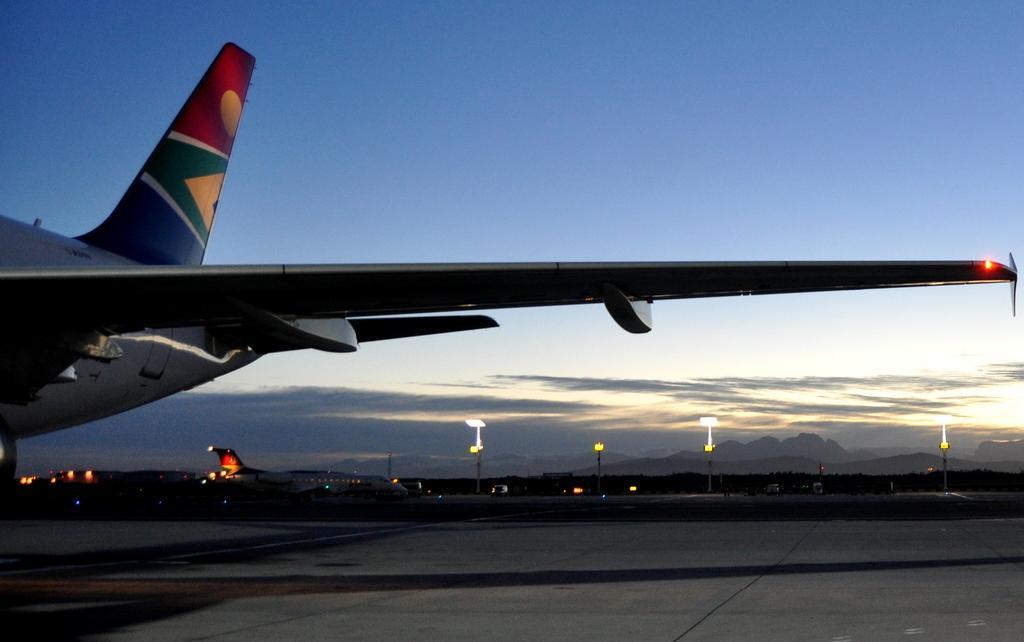Could you give a brief overview of what you see in this image? In the foreground of this image, there is a truncated air plane on the ground. In the background, there is an airplane moving on the runway, few poles, sky and the cloud. 